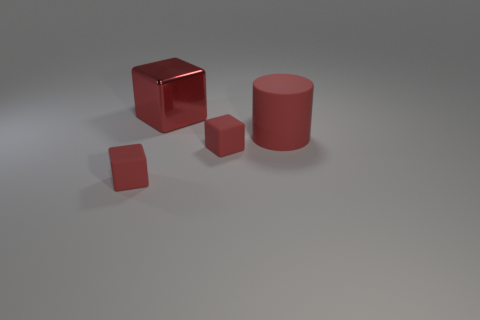Add 2 cylinders. How many objects exist? 6 Subtract all blocks. How many objects are left? 1 Subtract 0 yellow cylinders. How many objects are left? 4 Subtract all tiny matte things. Subtract all tiny matte cubes. How many objects are left? 0 Add 3 large cubes. How many large cubes are left? 4 Add 4 large brown matte cylinders. How many large brown matte cylinders exist? 4 